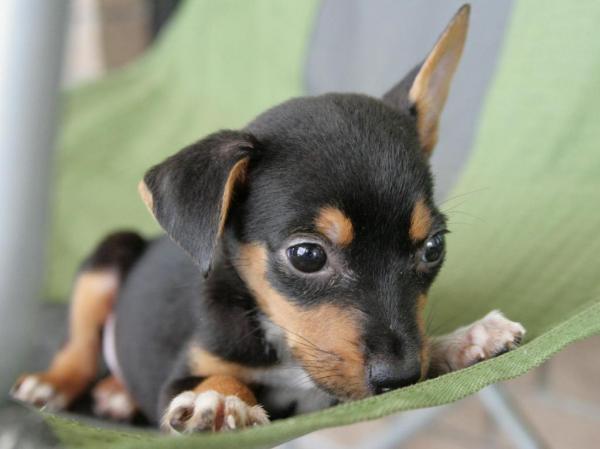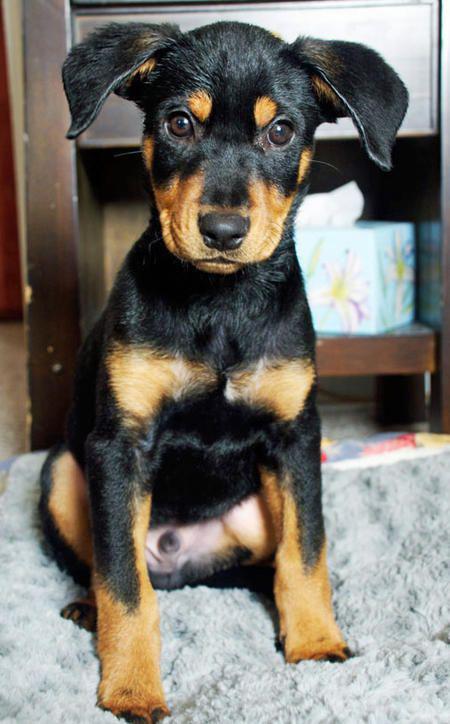The first image is the image on the left, the second image is the image on the right. Given the left and right images, does the statement "One Doberman's ears are both raised." hold true? Answer yes or no. No. The first image is the image on the left, the second image is the image on the right. Evaluate the accuracy of this statement regarding the images: "The right image shows a forward-facing reclining two-tone adult doberman with erect pointy ears.". Is it true? Answer yes or no. No. 